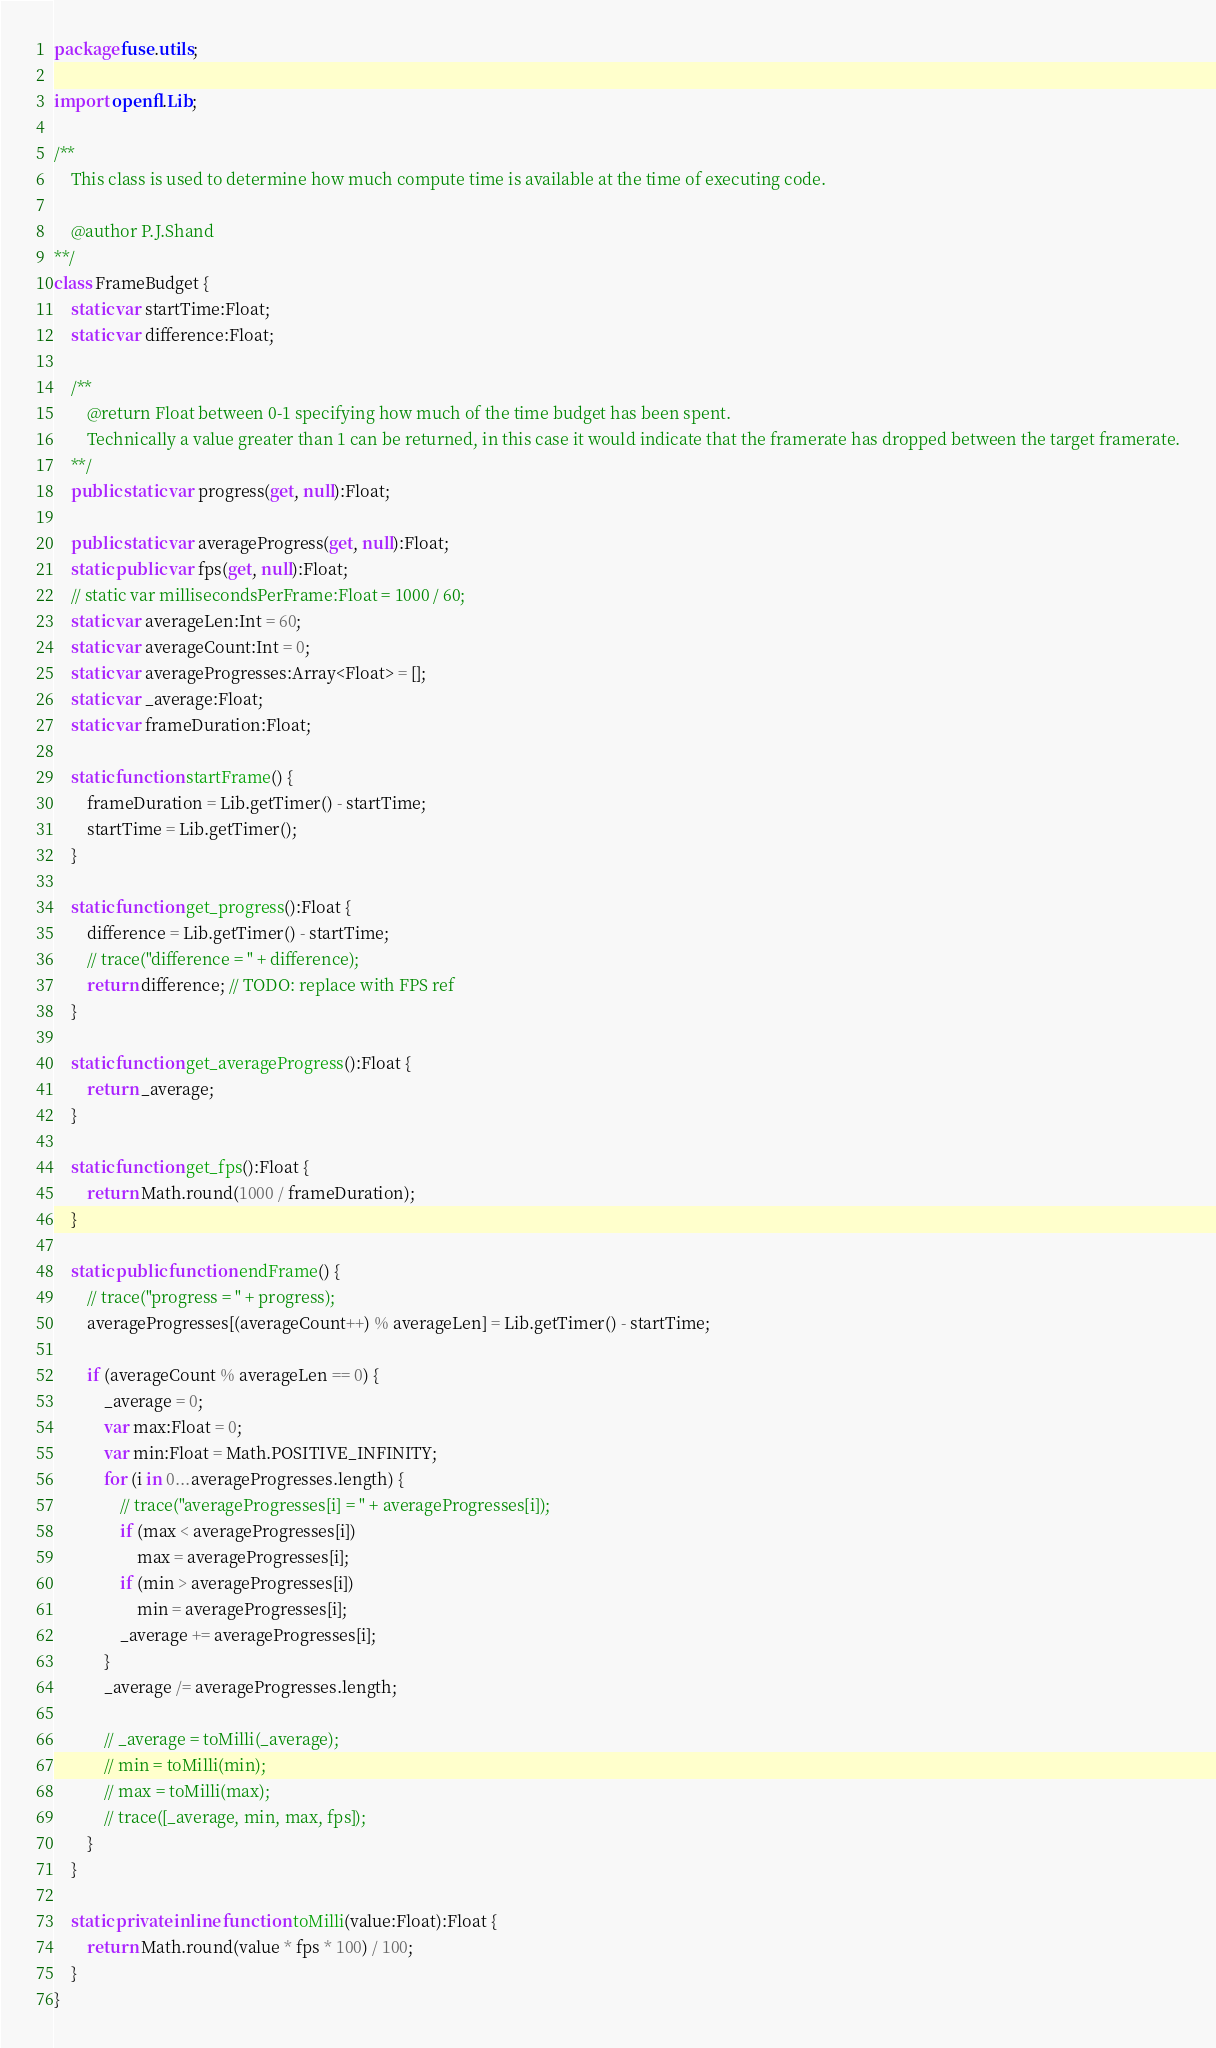Convert code to text. <code><loc_0><loc_0><loc_500><loc_500><_Haxe_>package fuse.utils;

import openfl.Lib;

/**
	This class is used to determine how much compute time is available at the time of executing code.

	@author P.J.Shand
**/
class FrameBudget {
	static var startTime:Float;
	static var difference:Float;

	/**
		@return Float between 0-1 specifying how much of the time budget has been spent.
		Technically a value greater than 1 can be returned, in this case it would indicate that the framerate has dropped between the target framerate.
	**/
	public static var progress(get, null):Float;

	public static var averageProgress(get, null):Float;
	static public var fps(get, null):Float;
	// static var millisecondsPerFrame:Float = 1000 / 60;
	static var averageLen:Int = 60;
	static var averageCount:Int = 0;
	static var averageProgresses:Array<Float> = [];
	static var _average:Float;
	static var frameDuration:Float;

	static function startFrame() {
		frameDuration = Lib.getTimer() - startTime;
		startTime = Lib.getTimer();
	}

	static function get_progress():Float {
		difference = Lib.getTimer() - startTime;
		// trace("difference = " + difference);
		return difference; // TODO: replace with FPS ref
	}

	static function get_averageProgress():Float {
		return _average;
	}

	static function get_fps():Float {
		return Math.round(1000 / frameDuration);
	}

	static public function endFrame() {
		// trace("progress = " + progress);
		averageProgresses[(averageCount++) % averageLen] = Lib.getTimer() - startTime;

		if (averageCount % averageLen == 0) {
			_average = 0;
			var max:Float = 0;
			var min:Float = Math.POSITIVE_INFINITY;
			for (i in 0...averageProgresses.length) {
				// trace("averageProgresses[i] = " + averageProgresses[i]);
				if (max < averageProgresses[i])
					max = averageProgresses[i];
				if (min > averageProgresses[i])
					min = averageProgresses[i];
				_average += averageProgresses[i];
			}
			_average /= averageProgresses.length;

			// _average = toMilli(_average);
			// min = toMilli(min);
			// max = toMilli(max);
			// trace([_average, min, max, fps]);
		}
	}

	static private inline function toMilli(value:Float):Float {
		return Math.round(value * fps * 100) / 100;
	}
}
</code> 